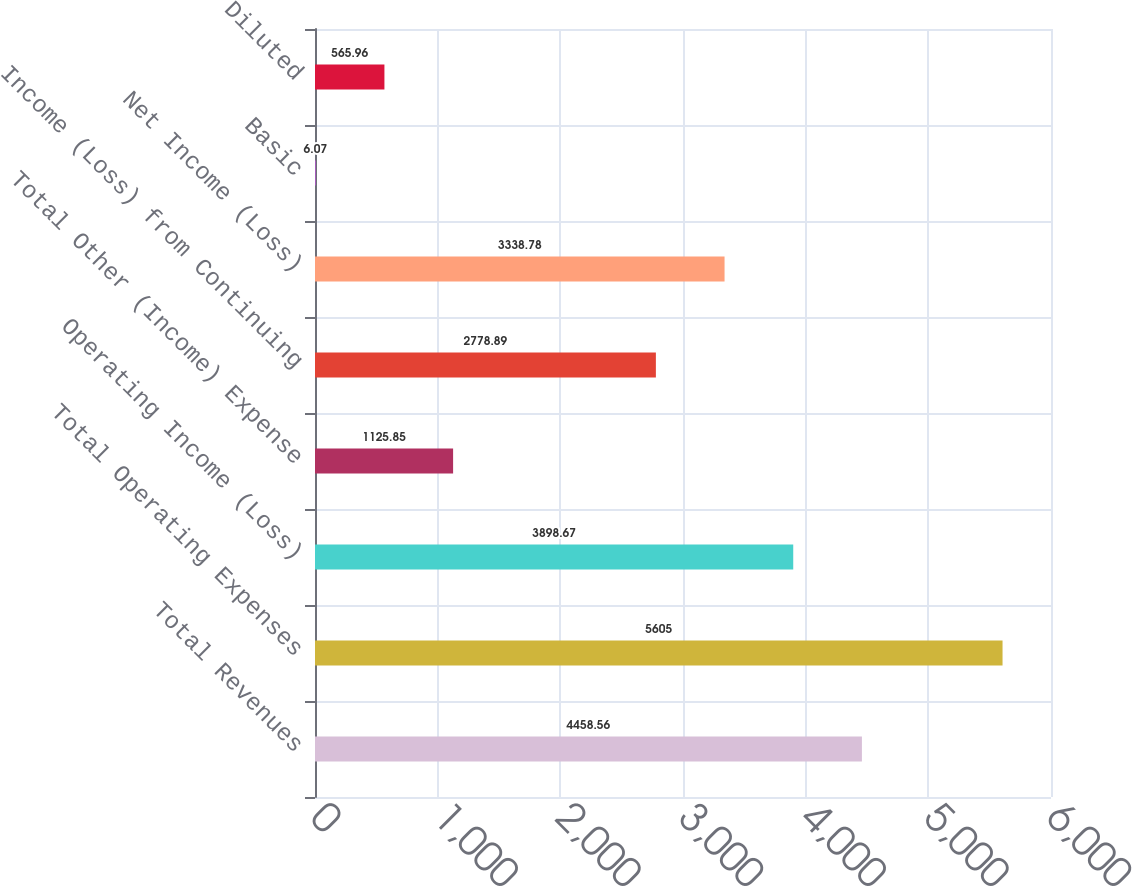Convert chart to OTSL. <chart><loc_0><loc_0><loc_500><loc_500><bar_chart><fcel>Total Revenues<fcel>Total Operating Expenses<fcel>Operating Income (Loss)<fcel>Total Other (Income) Expense<fcel>Income (Loss) from Continuing<fcel>Net Income (Loss)<fcel>Basic<fcel>Diluted<nl><fcel>4458.56<fcel>5605<fcel>3898.67<fcel>1125.85<fcel>2778.89<fcel>3338.78<fcel>6.07<fcel>565.96<nl></chart> 